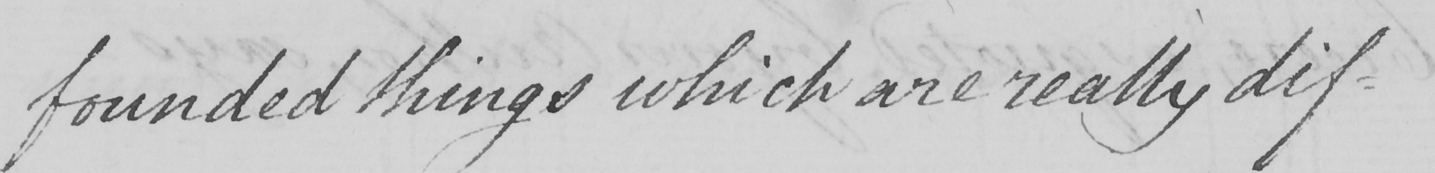What does this handwritten line say? founded things which are really dif- 